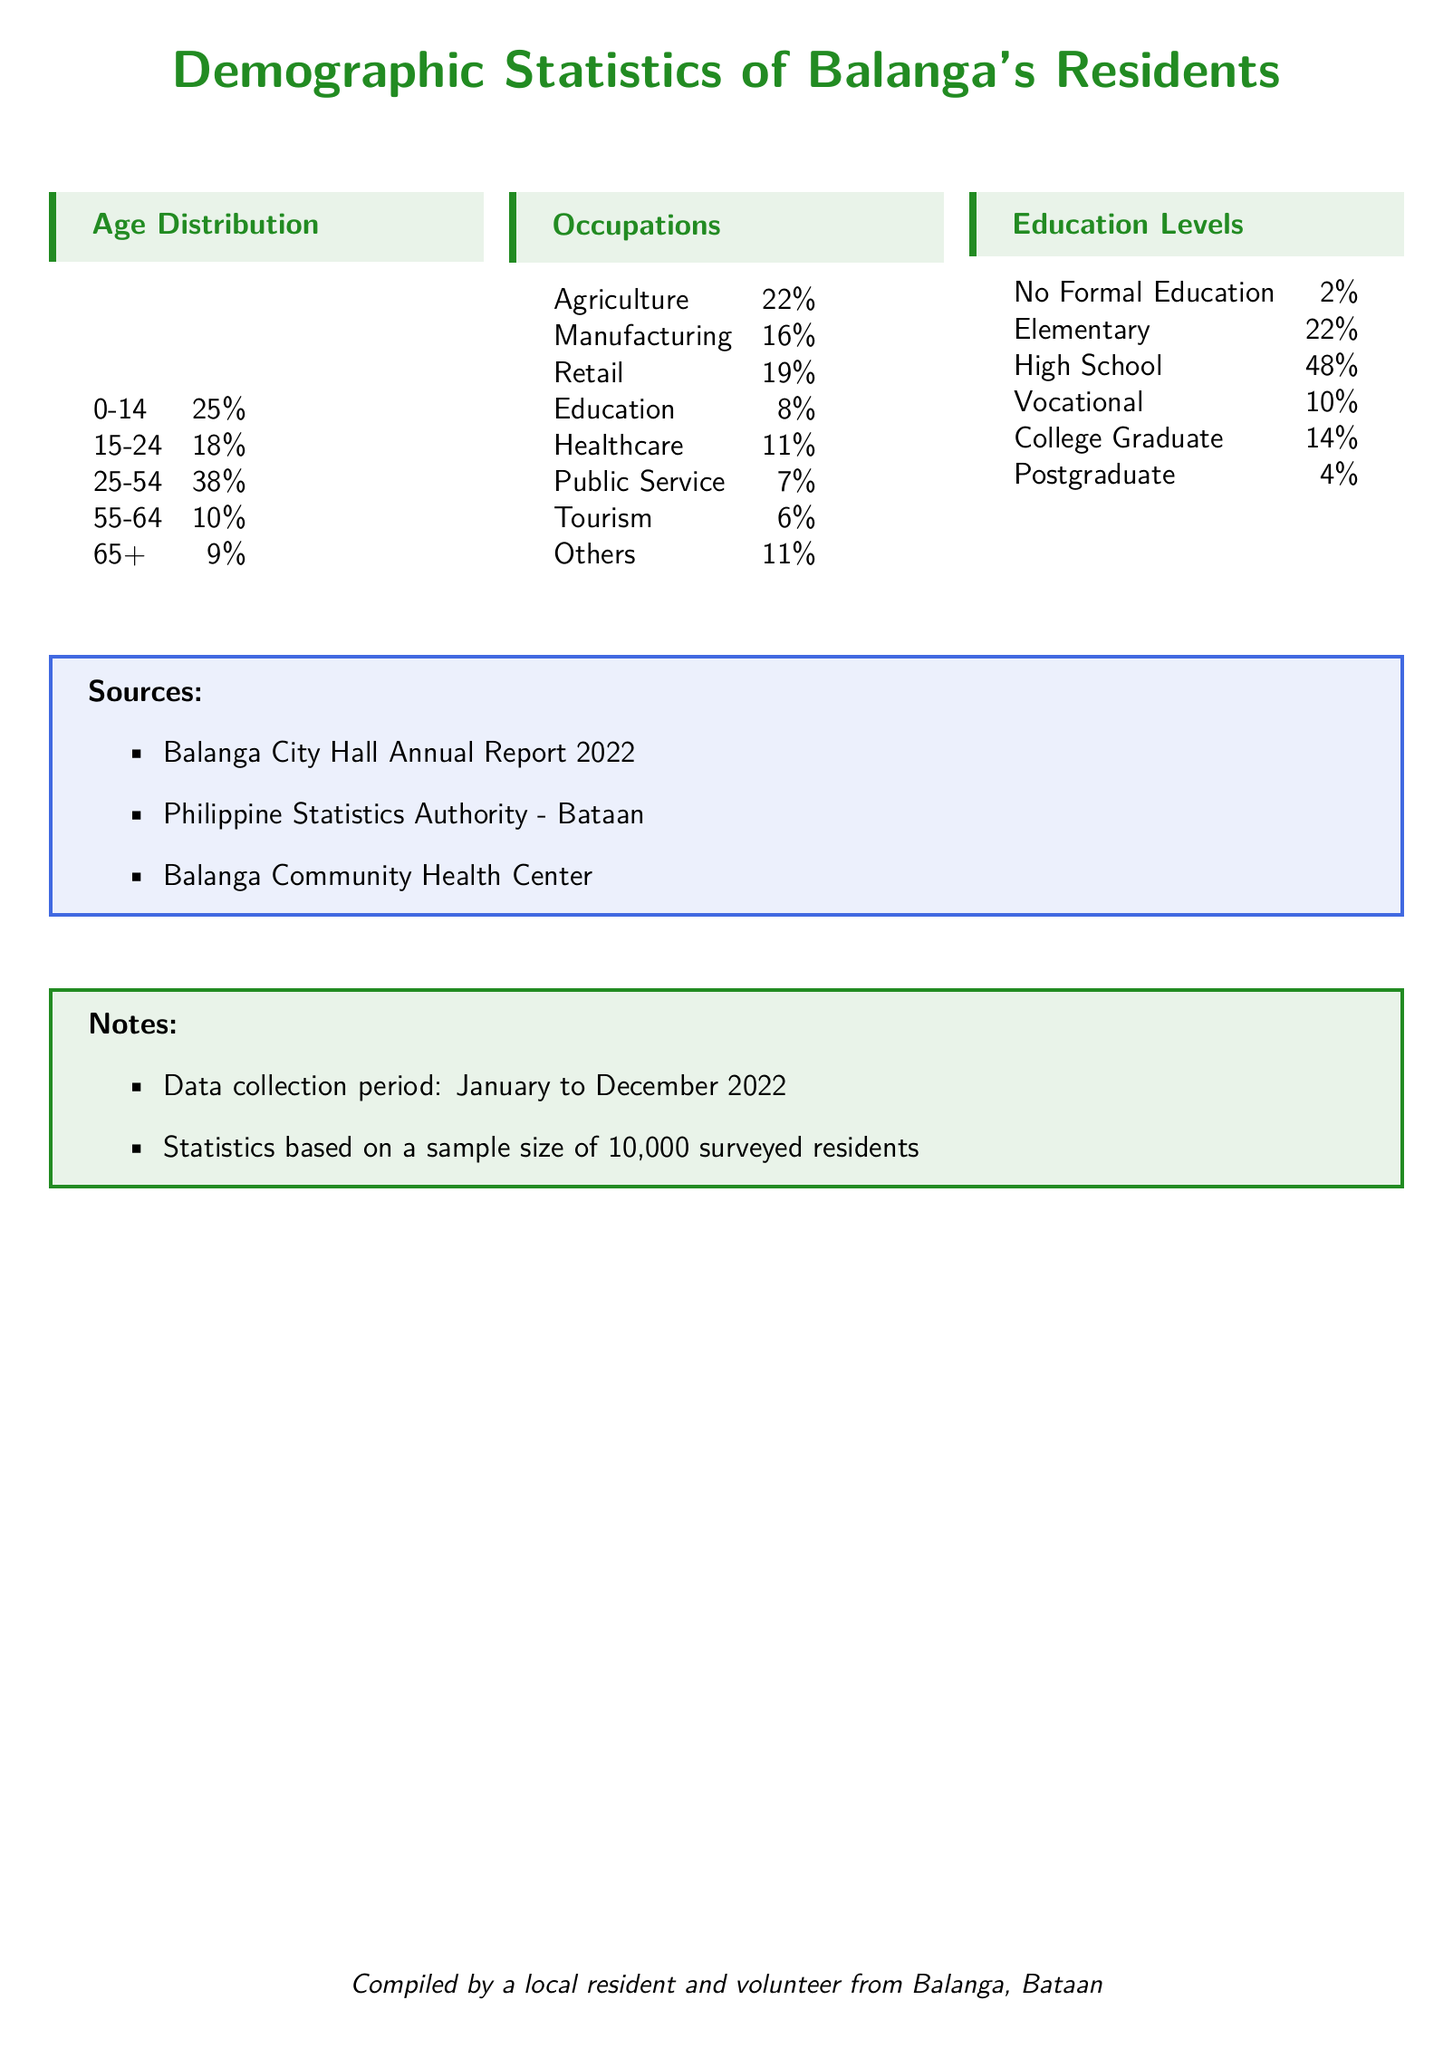what percentage of Balanga's residents are aged 0-14? The document states that 25% of the residents are in the age bracket of 0-14.
Answer: 25% what is the most common occupation in Balanga? According to the occupations listed, Agriculture is the most common occupation at 22%.
Answer: Agriculture how many percent of residents have no formal education? The document specifies that 2% of residents have no formal education.
Answer: 2% what age group constitutes the least percentage of the population? The age group 65+ constitutes the least percentage at 9%.
Answer: 9% what is the total percentage of residents working in Manufacturing and Retail combined? Adding the percentages of Manufacturing (16%) and Retail (19%) gives a total of 35%.
Answer: 35% which age group has the highest representation in the population? The age group 25-54 has the highest representation at 38%.
Answer: 38% what percentage of residents have completed a College Degree? The document indicates that 14% of residents are College Graduates.
Answer: 14% what is the percentage of residents employed in the Public Service sector? The document states that 7% of residents work in Public Service.
Answer: 7% which educational level has the highest representation in Balanga? High School has the highest representation with 48%.
Answer: 48% 